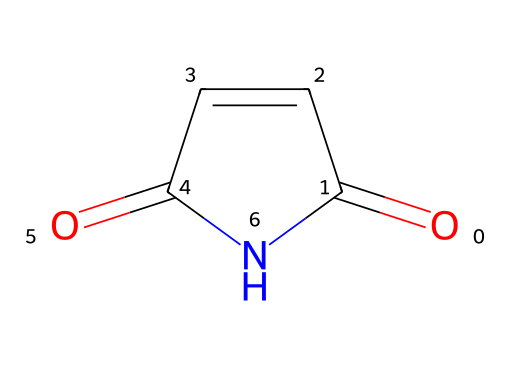What is the molecular formula of maleimide? To determine the molecular formula, we count the number of each type of atom in the SMILES representation. The structure indicates there are two carbon atoms (C), two oxygen atoms (O), and one nitrogen atom (N), leading to a molecular formula of C4H4N2O2.
Answer: C4H4N2O2 How many rings are present in maleimide? The structure reveals that there is one cyclic component forming a ring due to the 'C1' and 'N1' notations in the SMILES string, meaning it contains a single nitrogen atom in the ring.
Answer: 1 What types of functional groups are present in maleimide? By examining the structure, we observe two carbonyl (C=O) groups and one imide group, as indicated by the presence of nitrogen bonded to the carbonyl carbons.
Answer: carbonyl and imide What type of bonding is indicated by the presence of nitrogen and carbonyl groups? The presence of nitrogen connected to the carbonyl groups indicates the formation of a delocalized π-bonding system, characteristic of imides, which provides stability to the structure.
Answer: π-bonding How many hydrogen atoms are typically found in maleimide? In the SMILES representation, each carbon atom typically forms four bonds. Given the two carbonyls and structure, maleimide has four hydrogen atoms in total to satisfy carbon's bonding requirements in the imide configuration.
Answer: 4 Is maleimide classified as a saturated or unsaturated compound? Maleimide features double bonds among carbon and carbonyl groups, thus making it an unsaturated compound as it does not contain only single bonds.
Answer: unsaturated 